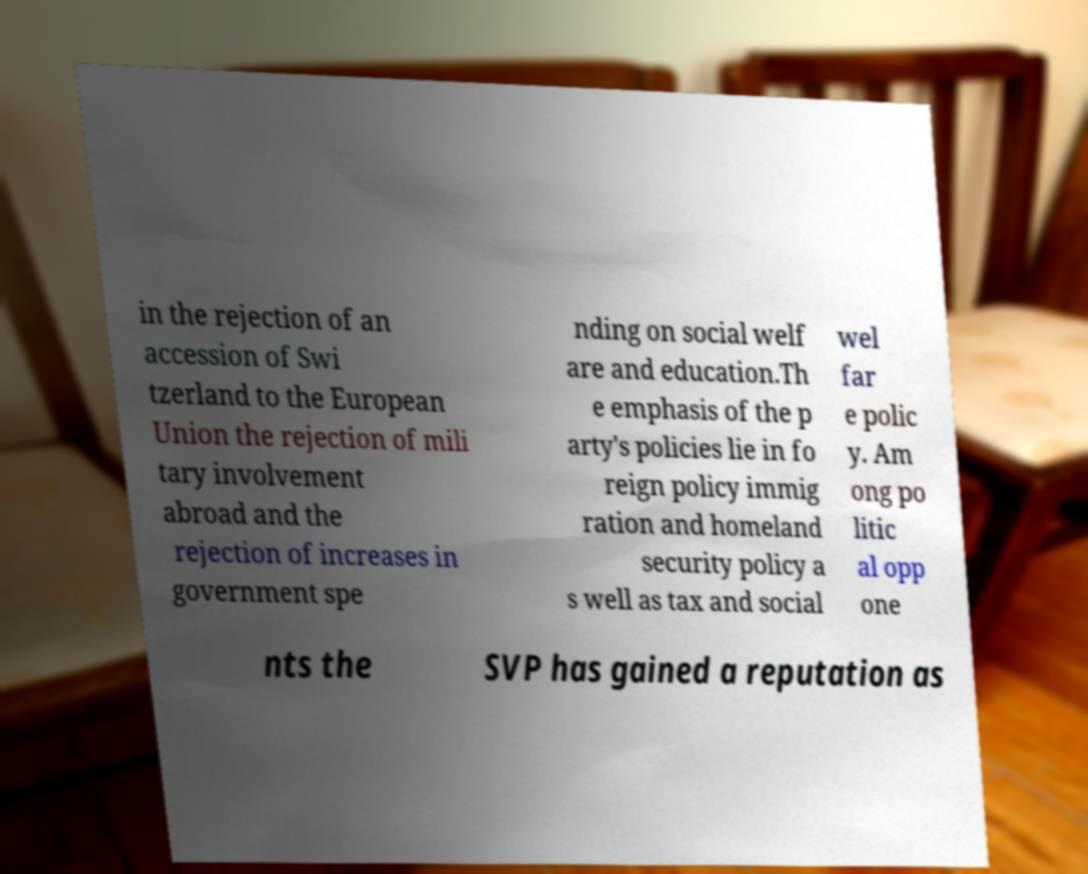Can you accurately transcribe the text from the provided image for me? in the rejection of an accession of Swi tzerland to the European Union the rejection of mili tary involvement abroad and the rejection of increases in government spe nding on social welf are and education.Th e emphasis of the p arty's policies lie in fo reign policy immig ration and homeland security policy a s well as tax and social wel far e polic y. Am ong po litic al opp one nts the SVP has gained a reputation as 